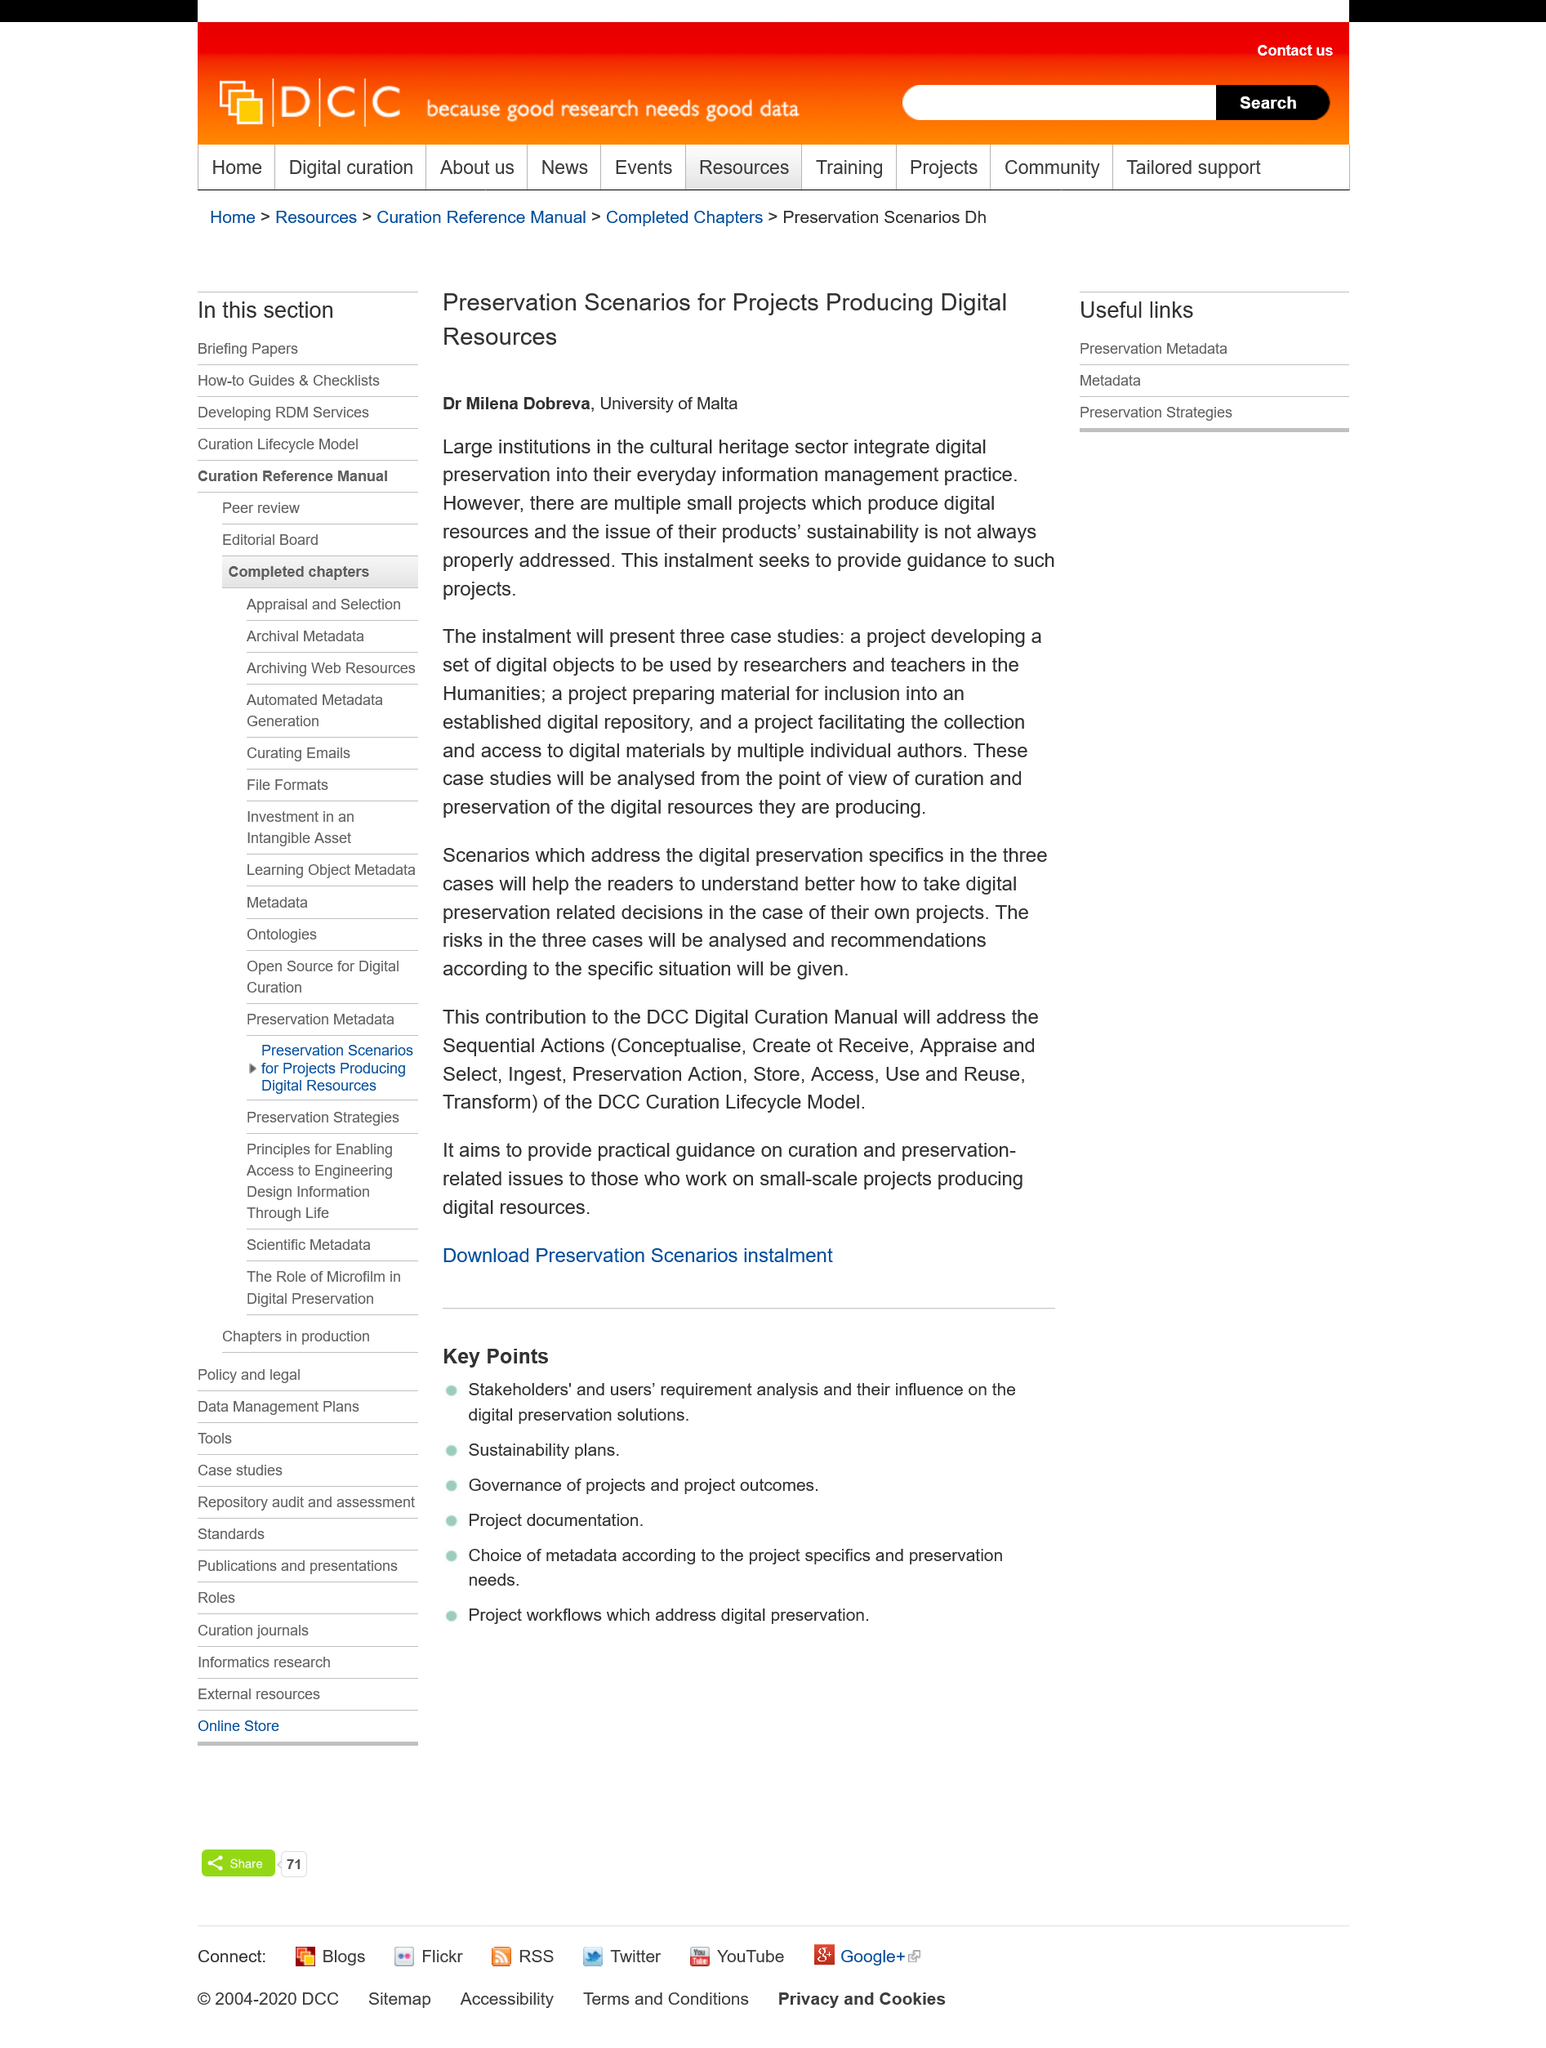Highlight a few significant elements in this photo. There is a significant issue with the long-term sustainability of preserving digital resources produced by small projects. The article is about the country of Malta, and the information provided in the article specifically relates to that country. It is possible for large institutions in the cultural heritage sector to integrate digital preservation into their everyday information management practices. 